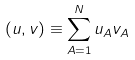Convert formula to latex. <formula><loc_0><loc_0><loc_500><loc_500>( u , v ) \equiv \sum _ { A = 1 } ^ { N } u _ { A } v _ { A }</formula> 